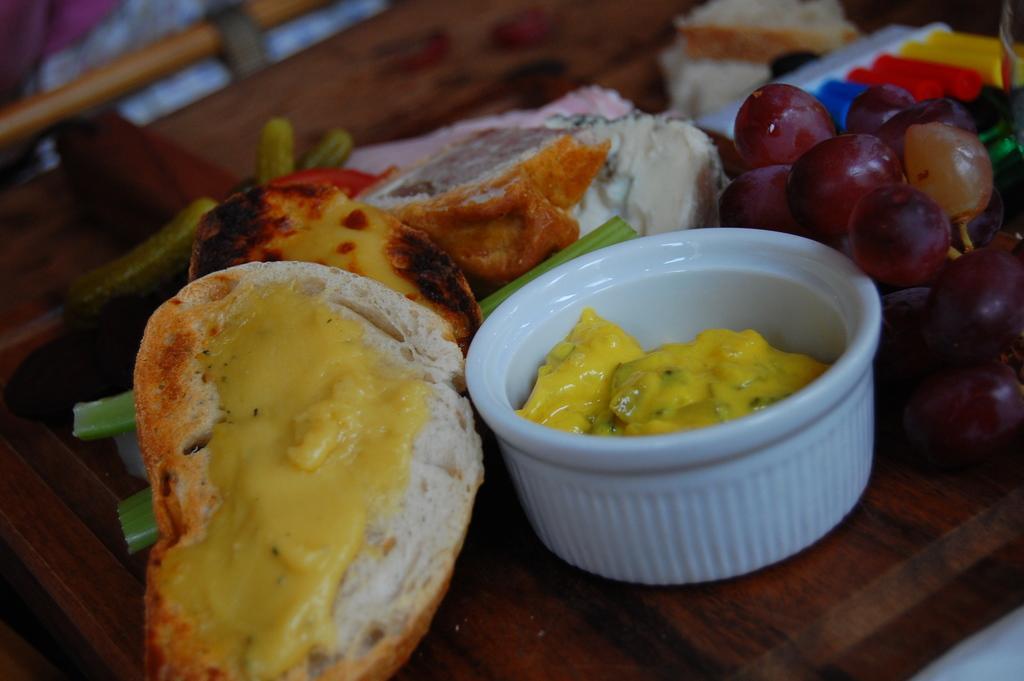Please provide a concise description of this image. In the foreground of this image, there is a bread with cream, a white bowl, grapes, spring onion, few objects and it seems like there is cake on a wooden surface. 